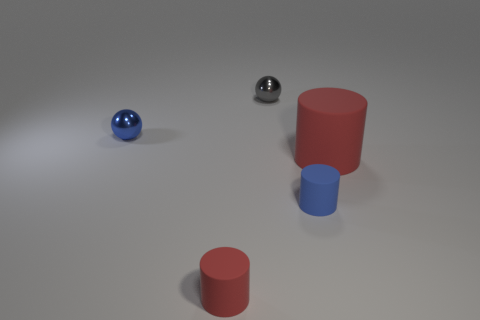Subtract all small blue matte cylinders. How many cylinders are left? 2 Add 2 big red shiny objects. How many objects exist? 7 Subtract all brown balls. How many red cylinders are left? 2 Subtract all blue cylinders. How many cylinders are left? 2 Subtract all balls. How many objects are left? 3 Subtract 2 cylinders. How many cylinders are left? 1 Add 5 tiny metal objects. How many tiny metal objects are left? 7 Add 4 red objects. How many red objects exist? 6 Subtract 0 green balls. How many objects are left? 5 Subtract all brown cylinders. Subtract all green blocks. How many cylinders are left? 3 